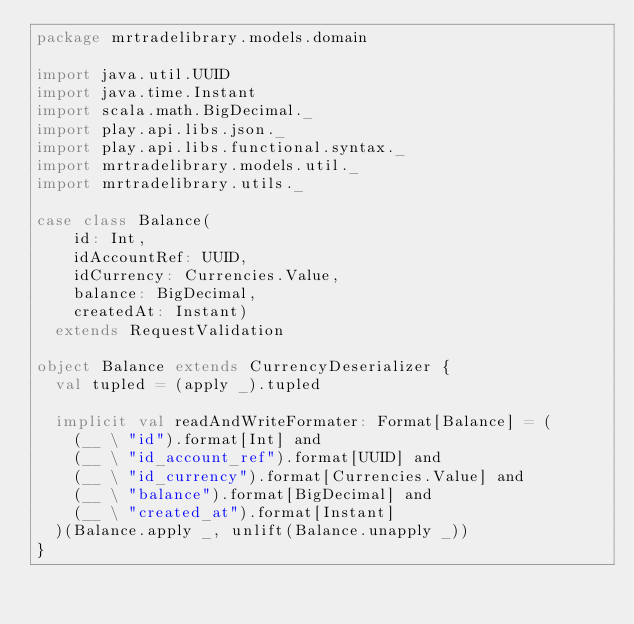Convert code to text. <code><loc_0><loc_0><loc_500><loc_500><_Scala_>package mrtradelibrary.models.domain

import java.util.UUID
import java.time.Instant
import scala.math.BigDecimal._
import play.api.libs.json._
import play.api.libs.functional.syntax._
import mrtradelibrary.models.util._
import mrtradelibrary.utils._

case class Balance(
    id: Int,
    idAccountRef: UUID,
    idCurrency: Currencies.Value,
    balance: BigDecimal,
    createdAt: Instant)
  extends RequestValidation

object Balance extends CurrencyDeserializer {
  val tupled = (apply _).tupled

  implicit val readAndWriteFormater: Format[Balance] = (
    (__ \ "id").format[Int] and
    (__ \ "id_account_ref").format[UUID] and
    (__ \ "id_currency").format[Currencies.Value] and
    (__ \ "balance").format[BigDecimal] and
    (__ \ "created_at").format[Instant]
  )(Balance.apply _, unlift(Balance.unapply _))
}
</code> 